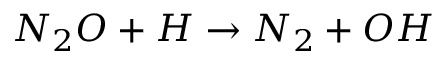Convert formula to latex. <formula><loc_0><loc_0><loc_500><loc_500>N _ { 2 } O + H \rightarrow N _ { 2 } + O H</formula> 